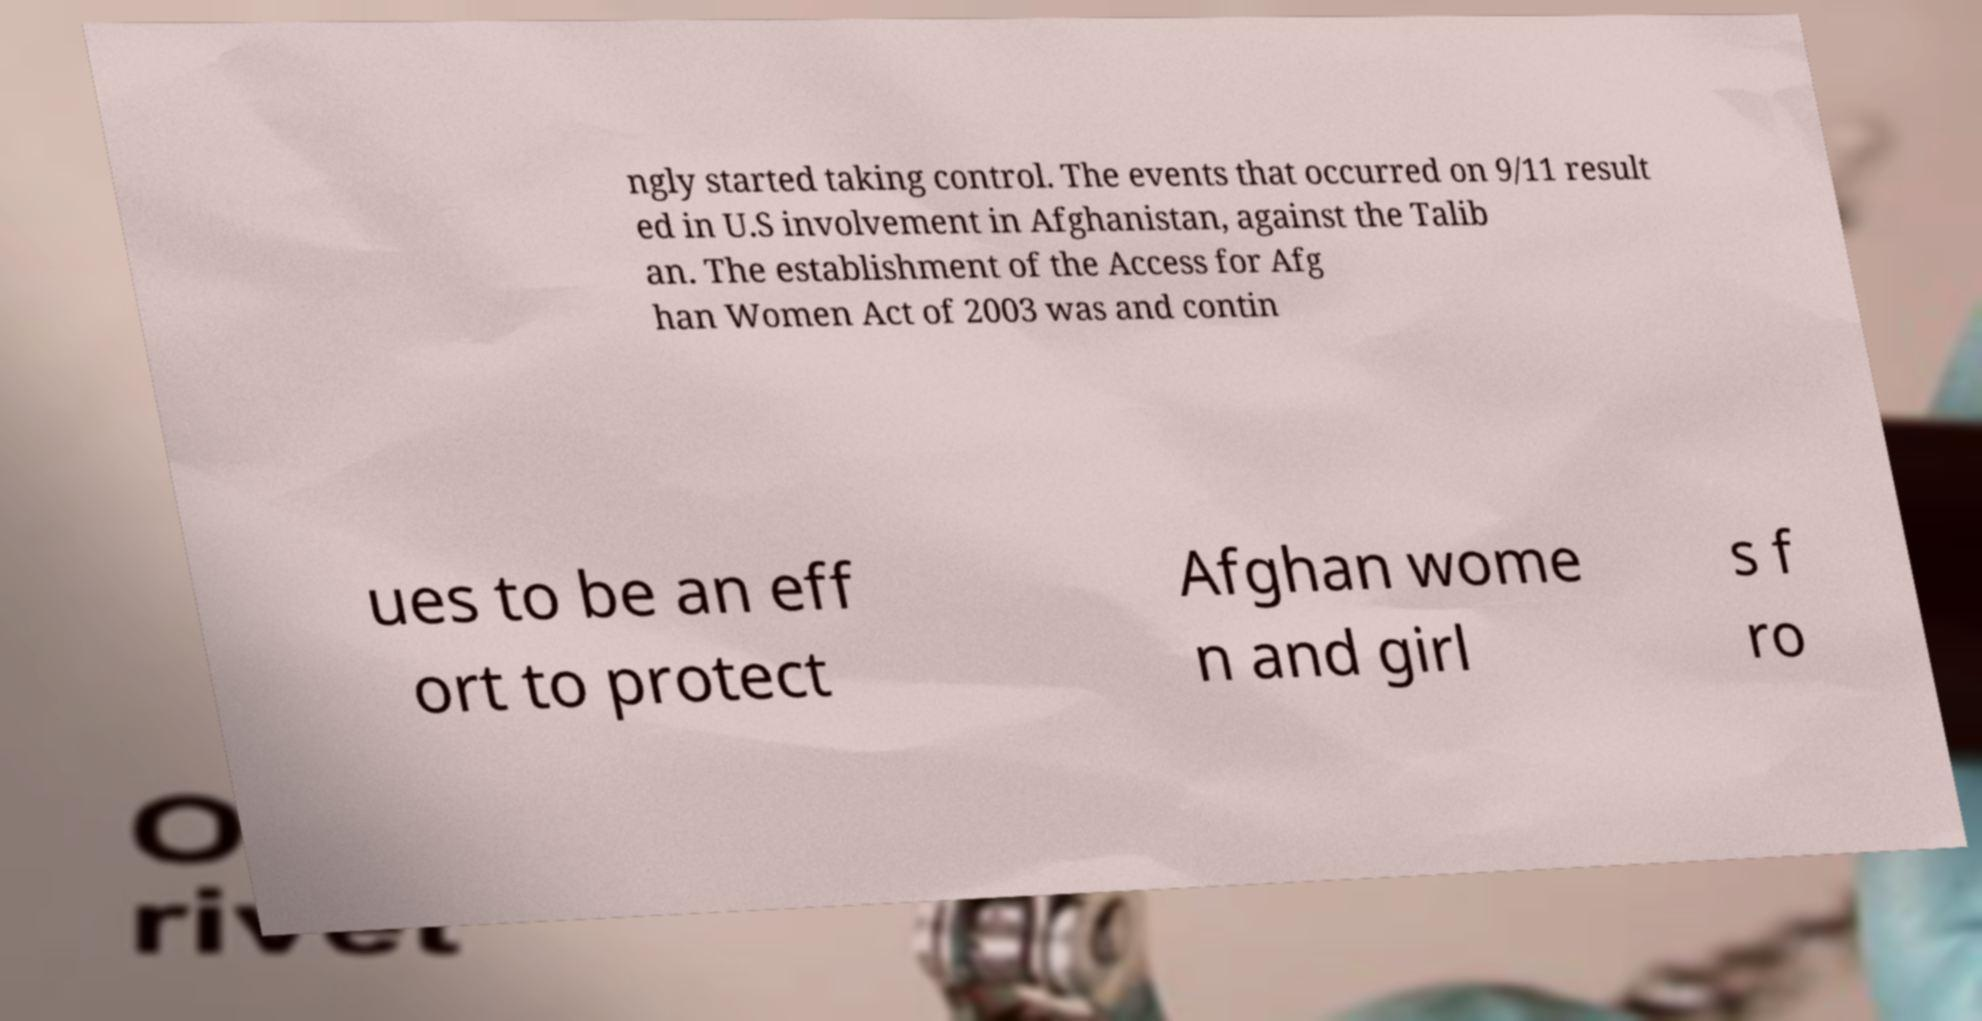Can you read and provide the text displayed in the image?This photo seems to have some interesting text. Can you extract and type it out for me? ngly started taking control. The events that occurred on 9/11 result ed in U.S involvement in Afghanistan, against the Talib an. The establishment of the Access for Afg han Women Act of 2003 was and contin ues to be an eff ort to protect Afghan wome n and girl s f ro 